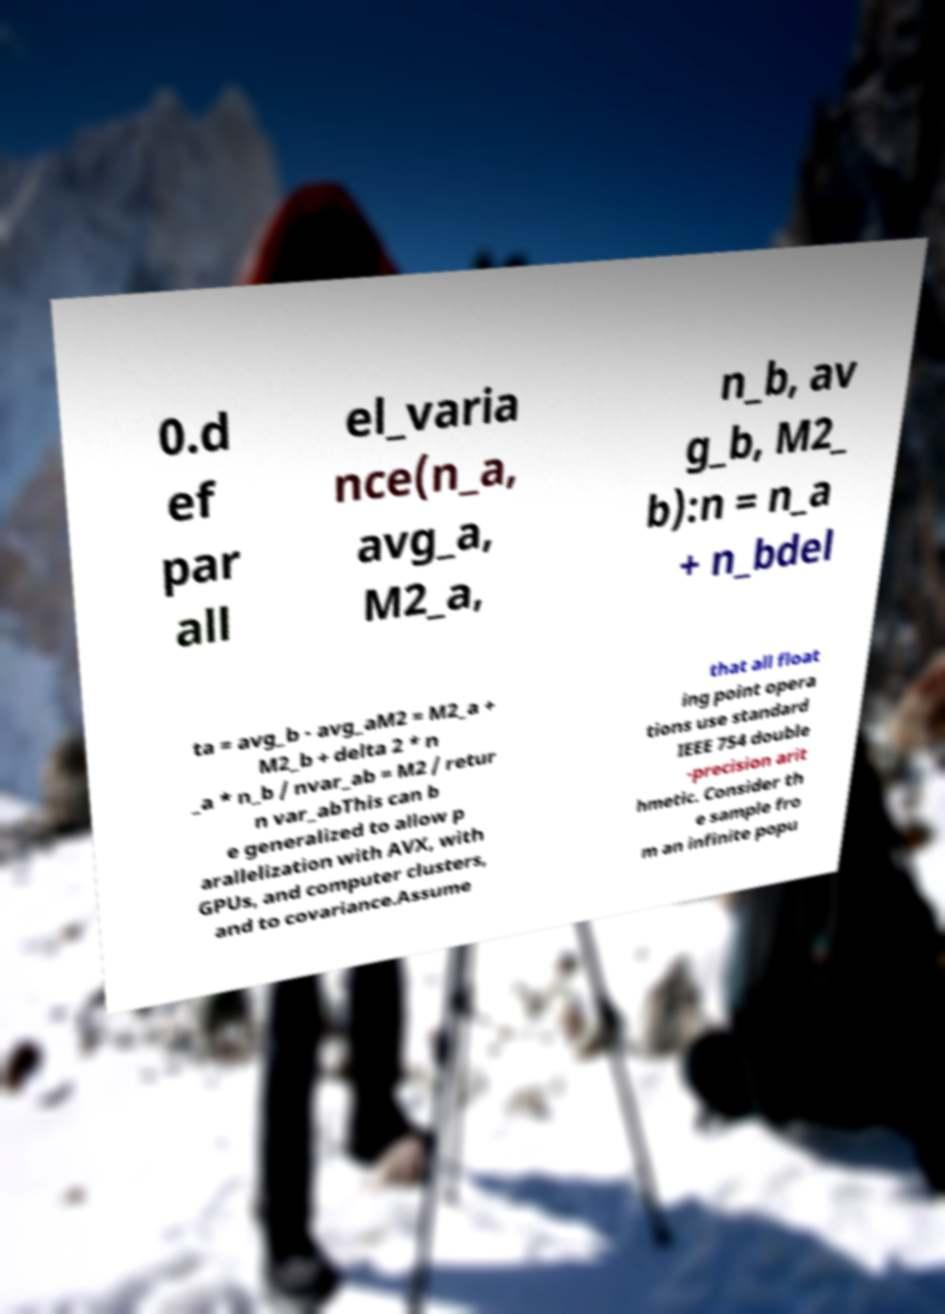Could you extract and type out the text from this image? 0.d ef par all el_varia nce(n_a, avg_a, M2_a, n_b, av g_b, M2_ b):n = n_a + n_bdel ta = avg_b - avg_aM2 = M2_a + M2_b + delta 2 * n _a * n_b / nvar_ab = M2 / retur n var_abThis can b e generalized to allow p arallelization with AVX, with GPUs, and computer clusters, and to covariance.Assume that all float ing point opera tions use standard IEEE 754 double -precision arit hmetic. Consider th e sample fro m an infinite popu 